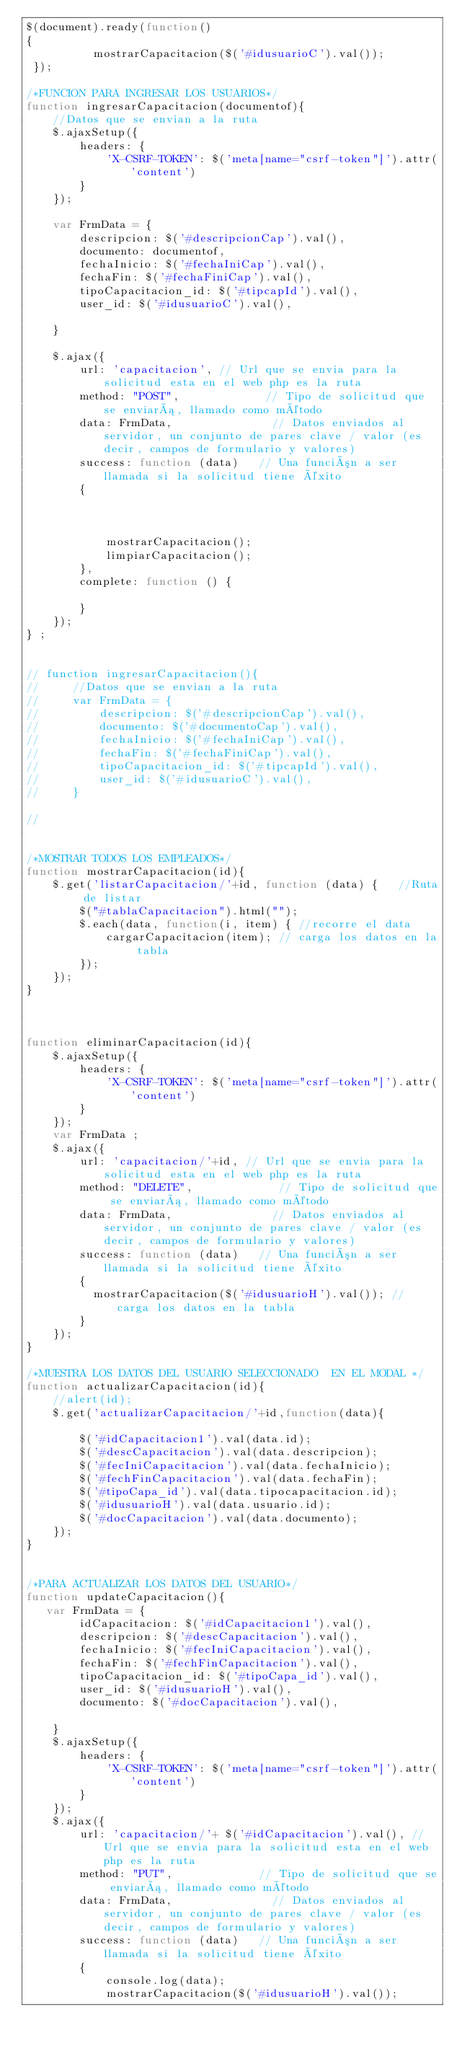Convert code to text. <code><loc_0><loc_0><loc_500><loc_500><_JavaScript_>$(document).ready(function()
{
          mostrarCapacitacion($('#idusuarioC').val());
 });

/*FUNCION PARA INGRESAR LOS USUARIOS*/
function ingresarCapacitacion(documentof){ 
    //Datos que se envian a la ruta
    $.ajaxSetup({
        headers: {
            'X-CSRF-TOKEN': $('meta[name="csrf-token"]').attr('content')
        }
    });

    var FrmData = {
        descripcion: $('#descripcionCap').val(),
        documento: documentof,
        fechaInicio: $('#fechaIniCap').val(),
        fechaFin: $('#fechaFiniCap').val(),
        tipoCapacitacion_id: $('#tipcapId').val(),
        user_id: $('#idusuarioC').val(),
        
    }

    $.ajax({
        url: 'capacitacion', // Url que se envia para la solicitud esta en el web php es la ruta
        method: "POST",             // Tipo de solicitud que se enviará, llamado como método
        data: FrmData,               // Datos enviados al servidor, un conjunto de pares clave / valor (es decir, campos de formulario y valores)
        success: function (data)   // Una función a ser llamada si la solicitud tiene éxito
        {
           
            
          
            mostrarCapacitacion();      
            limpiarCapacitacion();
        },
        complete: function () {     
           
        }
    });  
} ;


// function ingresarCapacitacion(){ 
//     //Datos que se envian a la ruta
//     var FrmData = {
//         descripcion: $('#descripcionCap').val(),
//         documento: $('#documentoCap').val(),
//         fechaInicio: $('#fechaIniCap').val(),
//         fechaFin: $('#fechaFiniCap').val(),
//         tipoCapacitacion_id: $('#tipcapId').val(),
//         user_id: $('#idusuarioC').val(),
//     }
    
//     


/*MOSTRAR TODOS LOS EMPLEADOS*/
function mostrarCapacitacion(id){
    $.get('listarCapacitacion/'+id, function (data) {   //Ruta de listar
        $("#tablaCapacitacion").html("");
        $.each(data, function(i, item) { //recorre el data 
            cargarCapacitacion(item); // carga los datos en la tabla
        });      
    });
}



function eliminarCapacitacion(id){
    $.ajaxSetup({
        headers: {
            'X-CSRF-TOKEN': $('meta[name="csrf-token"]').attr('content')
        }
    });
    var FrmData ;
    $.ajax({
        url: 'capacitacion/'+id, // Url que se envia para la solicitud esta en el web php es la ruta
        method: "DELETE",             // Tipo de solicitud que se enviará, llamado como método
        data: FrmData,               // Datos enviados al servidor, un conjunto de pares clave / valor (es decir, campos de formulario y valores)
        success: function (data)   // Una función a ser llamada si la solicitud tiene éxito
        {   
          mostrarCapacitacion($('#idusuarioH').val()); // carga los datos en la tabla                       
        }
    });
}

/*MUESTRA LOS DATOS DEL USUARIO SELECCIONADO  EN EL MODAL */
function actualizarCapacitacion(id){ 
    //alert(id);
    $.get('actualizarCapacitacion/'+id,function(data){
        
        $('#idCapacitacion1').val(data.id);
        $('#descCapacitacion').val(data.descripcion);
        $('#fecIniCapacitacion').val(data.fechaInicio);
        $('#fechFinCapacitacion').val(data.fechaFin);
        $('#tipoCapa_id').val(data.tipocapacitacion.id);
        $('#idusuarioH').val(data.usuario.id);
        $('#docCapacitacion').val(data.documento);
    });
}


/*PARA ACTUALIZAR LOS DATOS DEL USUARIO*/
function updateCapacitacion(){ 
   var FrmData = {
        idCapacitacion: $('#idCapacitacion1').val(),
        descripcion: $('#descCapacitacion').val(),
        fechaInicio: $('#fecIniCapacitacion').val(),
        fechaFin: $('#fechFinCapacitacion').val(),
        tipoCapacitacion_id: $('#tipoCapa_id').val(),
        user_id: $('#idusuarioH').val(),
        documento: $('#docCapacitacion').val(),

    }
    $.ajaxSetup({
        headers: {
            'X-CSRF-TOKEN': $('meta[name="csrf-token"]').attr('content')
        }
    });
    $.ajax({
        url: 'capacitacion/'+ $('#idCapacitacion').val(), // Url que se envia para la solicitud esta en el web php es la ruta
        method: "PUT",             // Tipo de solicitud que se enviará, llamado como método
        data: FrmData,               // Datos enviados al servidor, un conjunto de pares clave / valor (es decir, campos de formulario y valores)
        success: function (data)   // Una función a ser llamada si la solicitud tiene éxito
        {
            console.log(data);
            mostrarCapacitacion($('#idusuarioH').val()); </code> 